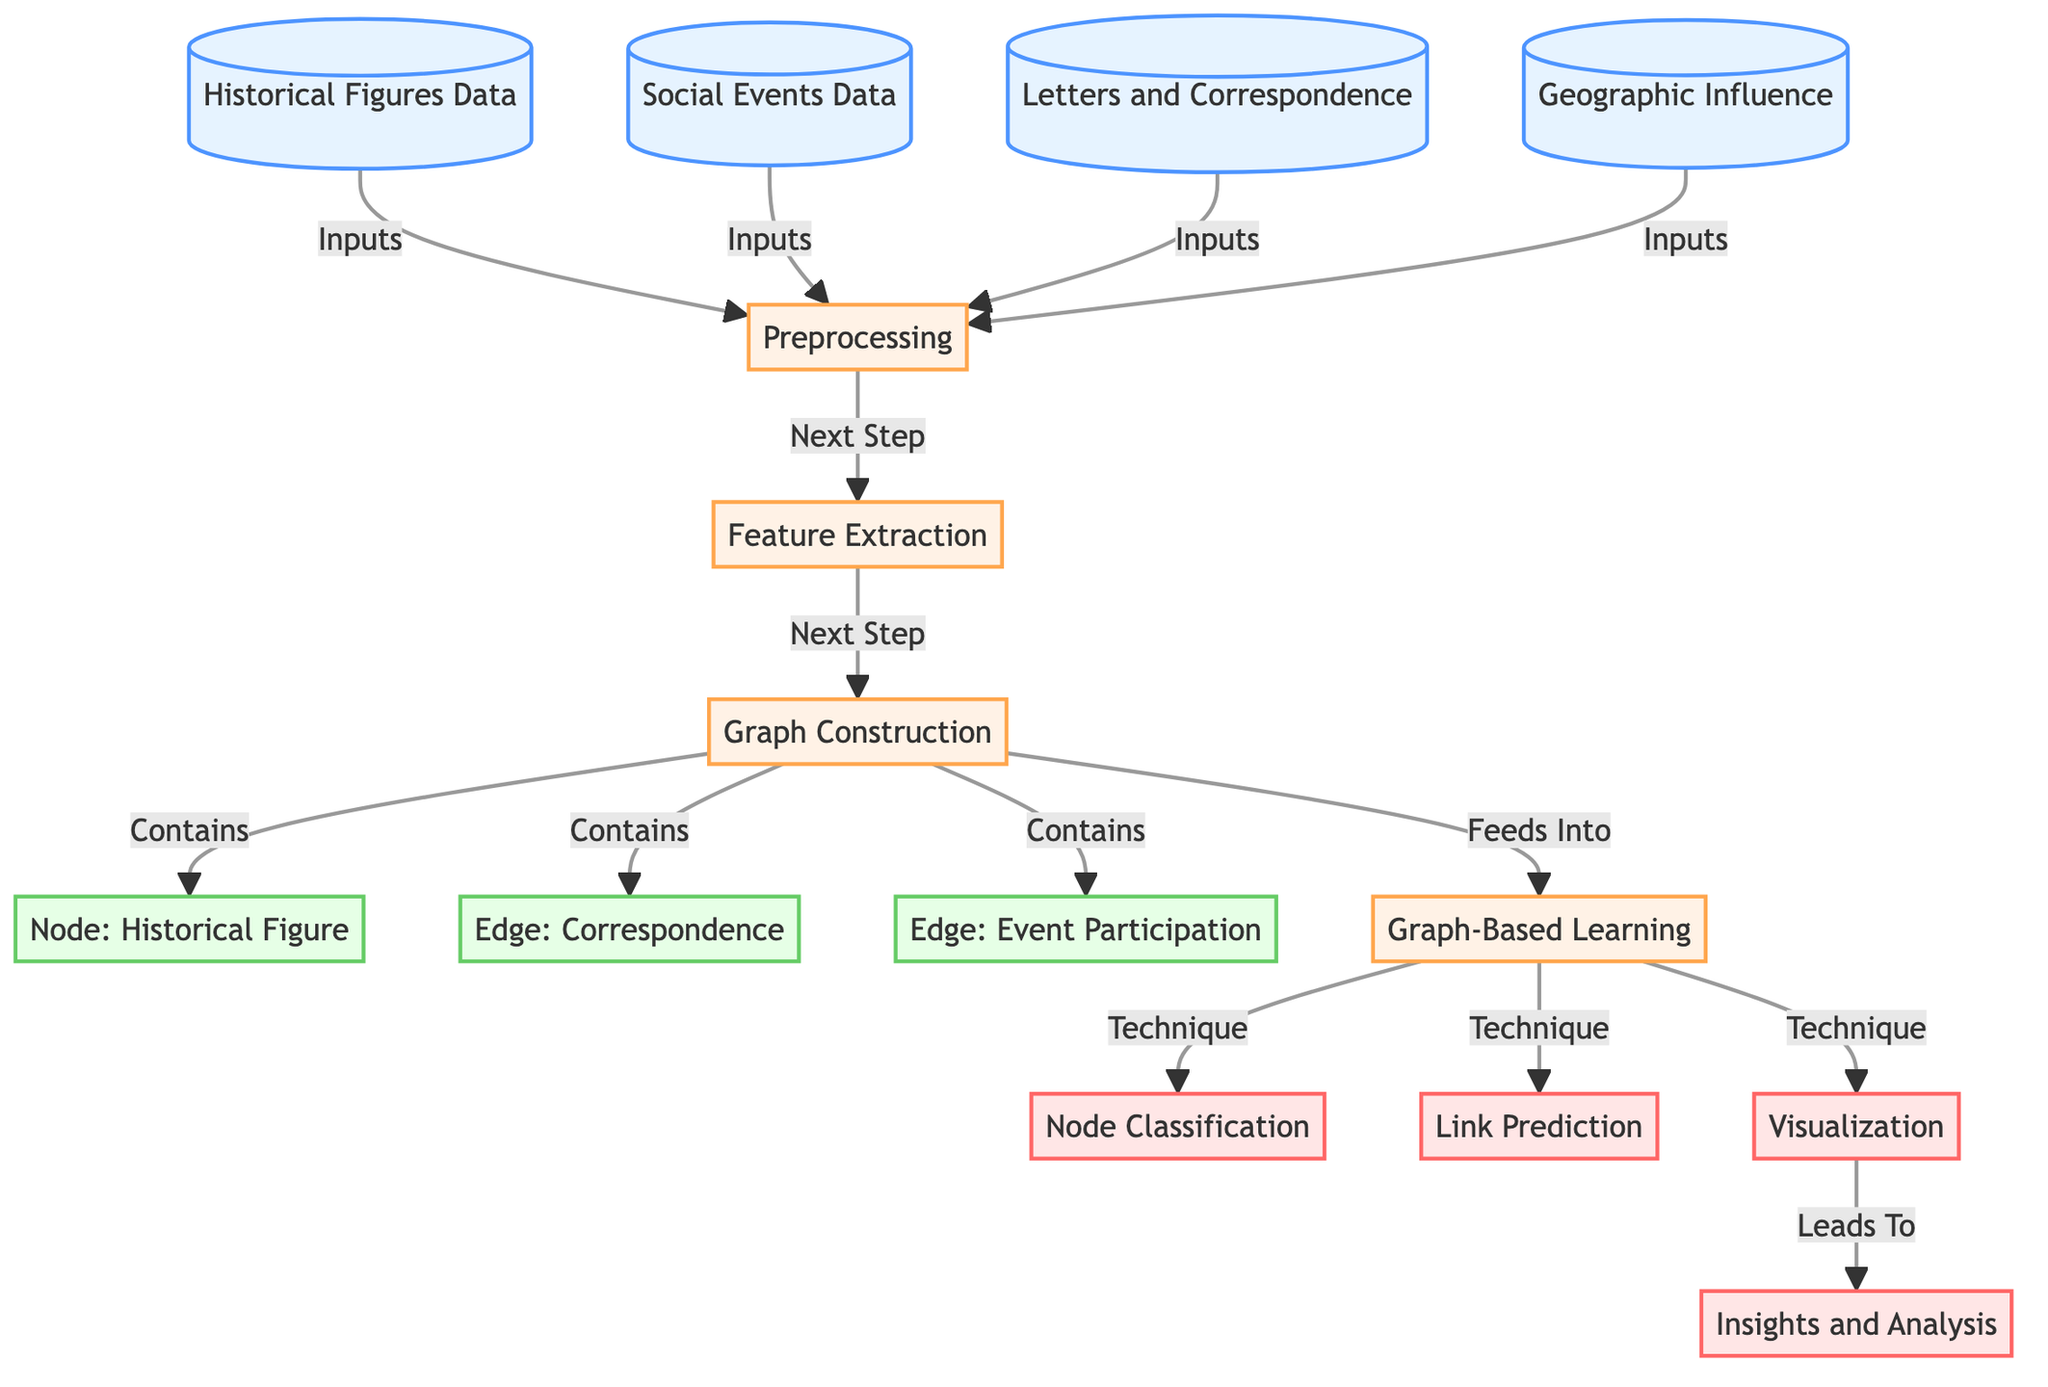What are the inputs used in the preprocessing step? The diagram indicates that there are four inputs entering the preprocessing step, which are "Historical Figures Data," "Social Events Data," "Letters and Correspondence," and "Geographic Influence."
Answer: Historical Figures Data, Social Events Data, Letters and Correspondence, Geographic Influence How many edges are mentioned in the graph construction? The graph construction node contains three edges, which are "Correspondence," "Event Participation," and another unspecified edge. The diagram explicitly states these edges as part of the graph structure.
Answer: Three What process follows the feature extraction? According to the flow of the diagram, after the feature extraction step, the next process is "Graph Construction." This is indicated by the directional flow between the nodes.
Answer: Graph Construction What type of learning is employed after graph construction? The node indicating the learning technique after graph construction is labeled "Graph-Based Learning." This suggests that this particular learning approach is utilized following the construction phase.
Answer: Graph-Based Learning Which node leads to the insights and analysis stage? The visualization node directly leads to the insights and analysis stage, as indicated by the directional flow from the "Visualization" node to the "Insights and Analysis" node.
Answer: Visualization What type of node represents "Historical Figure"? In the graph construction section, "Historical Figure" is categorized as a graph node, denoted by the specific label "Node: Historical Figure." This node represents the entities within the constructed graph.
Answer: Graph Node 